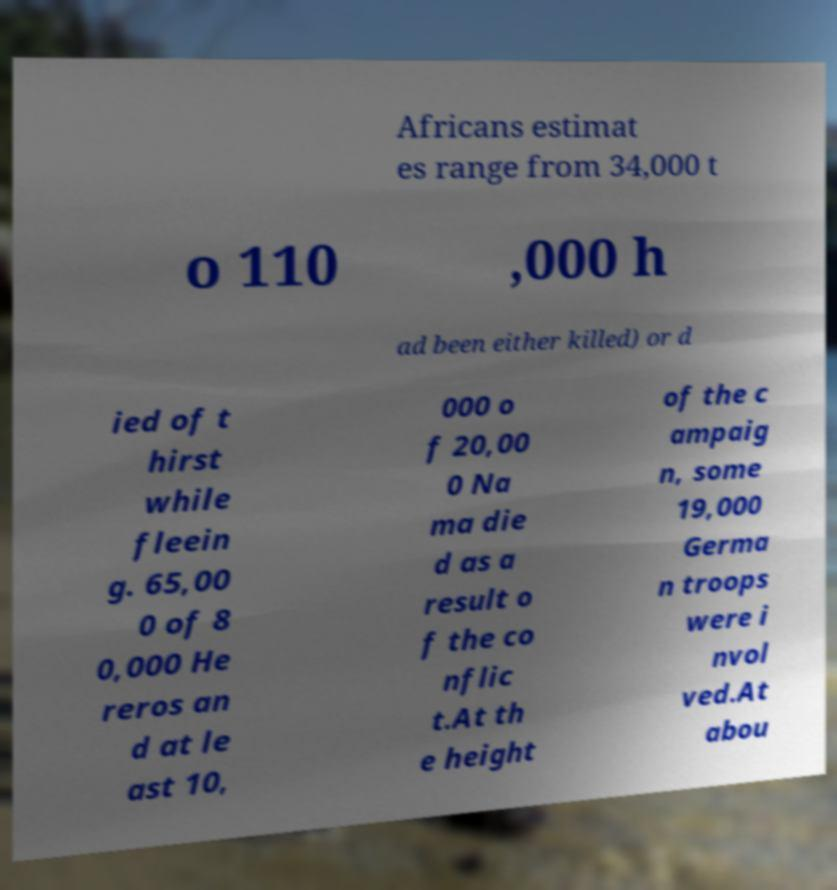Please read and relay the text visible in this image. What does it say? Africans estimat es range from 34,000 t o 110 ,000 h ad been either killed) or d ied of t hirst while fleein g. 65,00 0 of 8 0,000 He reros an d at le ast 10, 000 o f 20,00 0 Na ma die d as a result o f the co nflic t.At th e height of the c ampaig n, some 19,000 Germa n troops were i nvol ved.At abou 